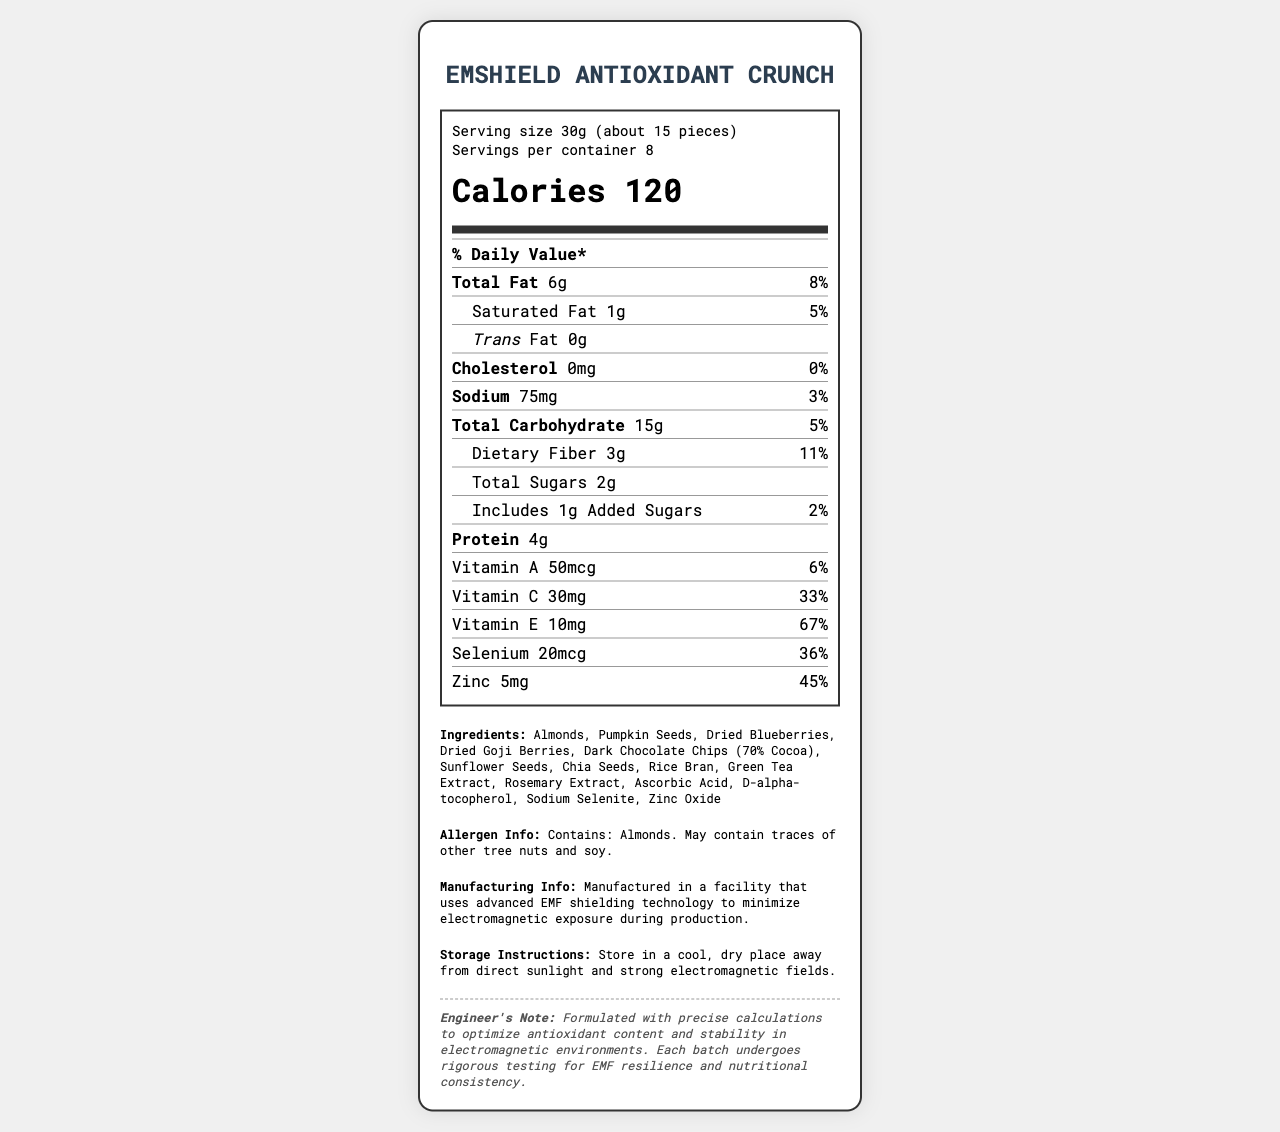what is the serving size of the EMShield Antioxidant Crunch? The serving size is listed at the top of the document under the serving info section as "Serving size 30g (about 15 pieces)".
Answer: 30g (about 15 pieces) how many calories are in one serving of the EMShield Antioxidant Crunch? The calories per serving are listed prominently in the document under the nutrition header as "Calories 120".
Answer: 120 what percentage of the daily value for Vitamin C does one serving of the EMShield Antioxidant Crunch provide? The document lists the Vitamin C content as 30mg with a daily value of 33%.
Answer: 33% is there any cholesterol in the EMShield Antioxidant Crunch? The document specifies that the cholesterol content is "0mg" with a daily value of "0%", indicating no cholesterol.
Answer: No which nutrient has the highest percentage of daily value in one serving? The document shows that Vitamin E provides 10mg per serving which is 67% of the daily value, the highest percentage among listed nutrients.
Answer: Vitamin E how many grams of protein are in one serving of the EMShield Antioxidant Crunch? The protein content per serving is listed in the document as "Protein 4g".
Answer: 4g are there any added sugars in the EMShield Antioxidant Crunch? The document indicates "Includes 1g Added Sugars," which means there are added sugars.
Answer: Yes what are the main ingredients of the EMShield Antioxidant Crunch? The ingredients are listed in the document under the "Ingredients" section.
Answer: Almonds, Pumpkin Seeds, Dried Blueberries, Dried Goji Berries, Dark Chocolate Chips (70% Cocoa), Sunflower Seeds, Chia Seeds, Rice Bran, Green Tea Extract, Rosemary Extract, Ascorbic Acid, D-alpha-tocopherol, Sodium Selenite, Zinc Oxide how should the EMShield Antioxidant Crunch be stored? Storage instructions are detailed in the document under the "Storage Instructions" section.
Answer: Store in a cool, dry place away from direct sunlight and strong electromagnetic fields. does the EMShield Antioxidant Crunch contain any allergens? Allergen information is provided in the document under the "Allergen Info" section.
Answer: Yes, it contains almonds and may contain traces of other tree nuts and soy. how many servings are in one container of the EMShield Antioxidant Crunch? A. 6 B. 7 C. 8 D. 9 The document specifies "Servings per container 8" under the serving info section.
Answer: C. 8 which ingredient is listed first in the EMShield Antioxidant Crunch? A. Pumpkin Seeds B. Almonds C. Dark Chocolate Chips D. Dried Blueberries In the ingredient list, almonds are listed first, indicating they are the primary ingredient.
Answer: B. Almonds does the EMShield Antioxidant Crunch product have any trans fats? The document lists the trans fat as "0g," indicating there are no trans fats.
Answer: No does the manufacturing facility use any special technology? The document states that the product is manufactured in a facility that uses advanced EMF shielding technology to minimize electromagnetic exposure during production.
Answer: Yes summarize the main purpose and features of the EMShield Antioxidant Crunch. This summary includes the main idea from the name, nutritional highlights, components, and special manufacturing features, providing a complete overview of the product.
Answer: The EMShield Antioxidant Crunch is a snack designed to combat the effects of prolonged exposure to electromagnetic fields through its rich antioxidant content. Each serving offers 120 calories, low cholesterol, and significant amounts of vitamins and minerals like Vitamin E, Selenium, and Zinc. It contains natural ingredients like almonds, pumpkin seeds, and dark chocolate chips, and is manufactured in a specialized facility with EMF shielding technology. The product should be stored in a cool, dry place away from electromagnetic fields. It also contains almonds and may have traces of other nuts and soy. what is the average shelf life of the EMShield Antioxidant Crunch? The document does not provide any information regarding the shelf life of the product.
Answer: Cannot be determined 